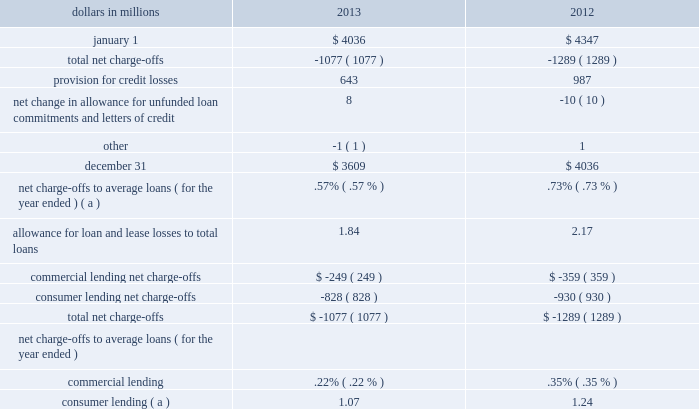Table 46 : allowance for loan and lease losses .
( a ) includes charge-offs of $ 134 million taken pursuant to alignment with interagency guidance on practices for loans and lines of credit related to consumer lending in the first quarter of 2013 .
The provision for credit losses totaled $ 643 million for 2013 compared to $ 987 million for 2012 .
The primary driver of the decrease to the provision was improved overall credit quality , including improved commercial loan risk factors , lower consumer loan delinquencies and improvements in expected cash flows for our purchased impaired loans .
For 2013 , the provision for commercial lending credit losses decreased by $ 102 million , or 74% ( 74 % ) , from 2012 .
The provision for consumer lending credit losses decreased $ 242 million , or 29% ( 29 % ) , from 2012 .
At december 31 , 2013 , total alll to total nonperforming loans was 117% ( 117 % ) .
The comparable amount for december 31 , 2012 was 124% ( 124 % ) .
These ratios are 72% ( 72 % ) and 79% ( 79 % ) , respectively , when excluding the $ 1.4 billion and $ 1.5 billion , respectively , of alll at december 31 , 2013 and december 31 , 2012 allocated to consumer loans and lines of credit not secured by residential real estate and purchased impaired loans .
We have excluded consumer loans and lines of credit not secured by real estate as they are charged off after 120 to 180 days past due and not placed on nonperforming status .
Additionally , we have excluded purchased impaired loans as they are considered performing regardless of their delinquency status as interest is accreted based on our estimate of expected cash flows and additional allowance is recorded when these cash flows are below recorded investment .
See table 35 within this credit risk management section for additional information .
The alll balance increases or decreases across periods in relation to fluctuating risk factors , including asset quality trends , charge-offs and changes in aggregate portfolio balances .
During 2013 , improving asset quality trends , including , but not limited to , delinquency status and improving economic conditions , realization of previously estimated losses through charge-offs , including the impact of alignment with interagency guidance and overall portfolio growth , combined to result in the alll balance declining $ .4 billion , or 11% ( 11 % ) to $ 3.6 billion as of december 31 , 2013 compared to december 31 , 2012 .
See note 7 allowances for loan and lease losses and unfunded loan commitments and letters of credit and note 6 purchased loans in the notes to consolidated financial statements in item 8 of this report regarding changes in the alll and in the allowance for unfunded loan commitments and letters of credit .
Operational risk management operational risk is the risk of loss resulting from inadequate or failed internal processes or systems , human factors , or external events .
This includes losses that may arise as a result of non- compliance with laws or regulations , failure to fulfill fiduciary responsibilities , as well as litigation or other legal actions .
Operational risk may occur in any of our business activities and manifests itself in various ways , including but not limited to : 2022 transaction processing errors , 2022 unauthorized transactions and fraud by employees or third parties , 2022 material disruption in business activities , 2022 system breaches and misuse of sensitive information , 2022 regulatory or governmental actions , fines or penalties , and 2022 significant legal expenses , judgments or settlements .
Pnc 2019s operational risk management is inclusive of technology risk management , compliance and business continuity risk .
Operational risk management focuses on balancing business needs , regulatory expectations and risk management priorities through an adaptive and proactive program that is designed to provide a strong governance model , sound and consistent risk management processes and transparent operational risk reporting across the enterprise .
The pnc board determines the strategic approach to operational risk via establishment of the operational risk appetite and appropriate risk management structure .
This includes establishment of risk metrics and limits and a reporting structure to identify , understand and manage operational risks .
Executive management has responsibility for operational risk management .
The executive management team is responsible for monitoring significant risks , key controls and related issues through management reporting and a governance structure of risk committees and sub-committees .
Within risk management , operational risk management functions are responsible for developing and maintaining the 84 the pnc financial services group , inc .
2013 form 10-k .
What was the percentage change in the provision for credit losses from 2012 to 2013? 
Computations: ((643 - 987) / 987)
Answer: -0.34853. 